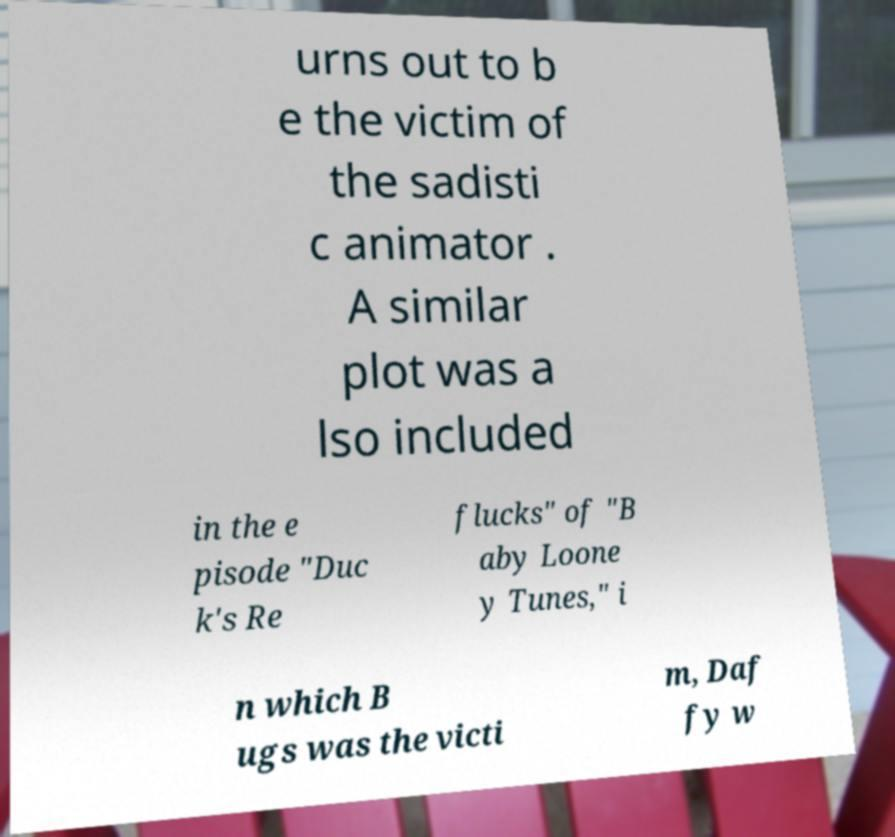For documentation purposes, I need the text within this image transcribed. Could you provide that? urns out to b e the victim of the sadisti c animator . A similar plot was a lso included in the e pisode "Duc k's Re flucks" of "B aby Loone y Tunes," i n which B ugs was the victi m, Daf fy w 